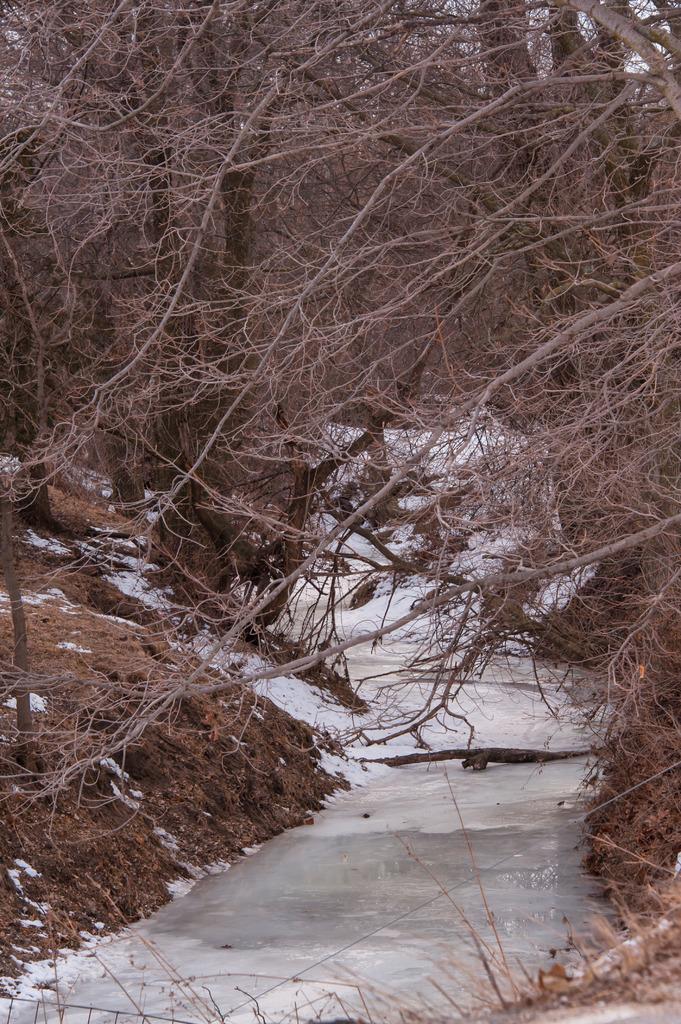Please provide a concise description of this image. In this image we can see a trees, here is the ice. 